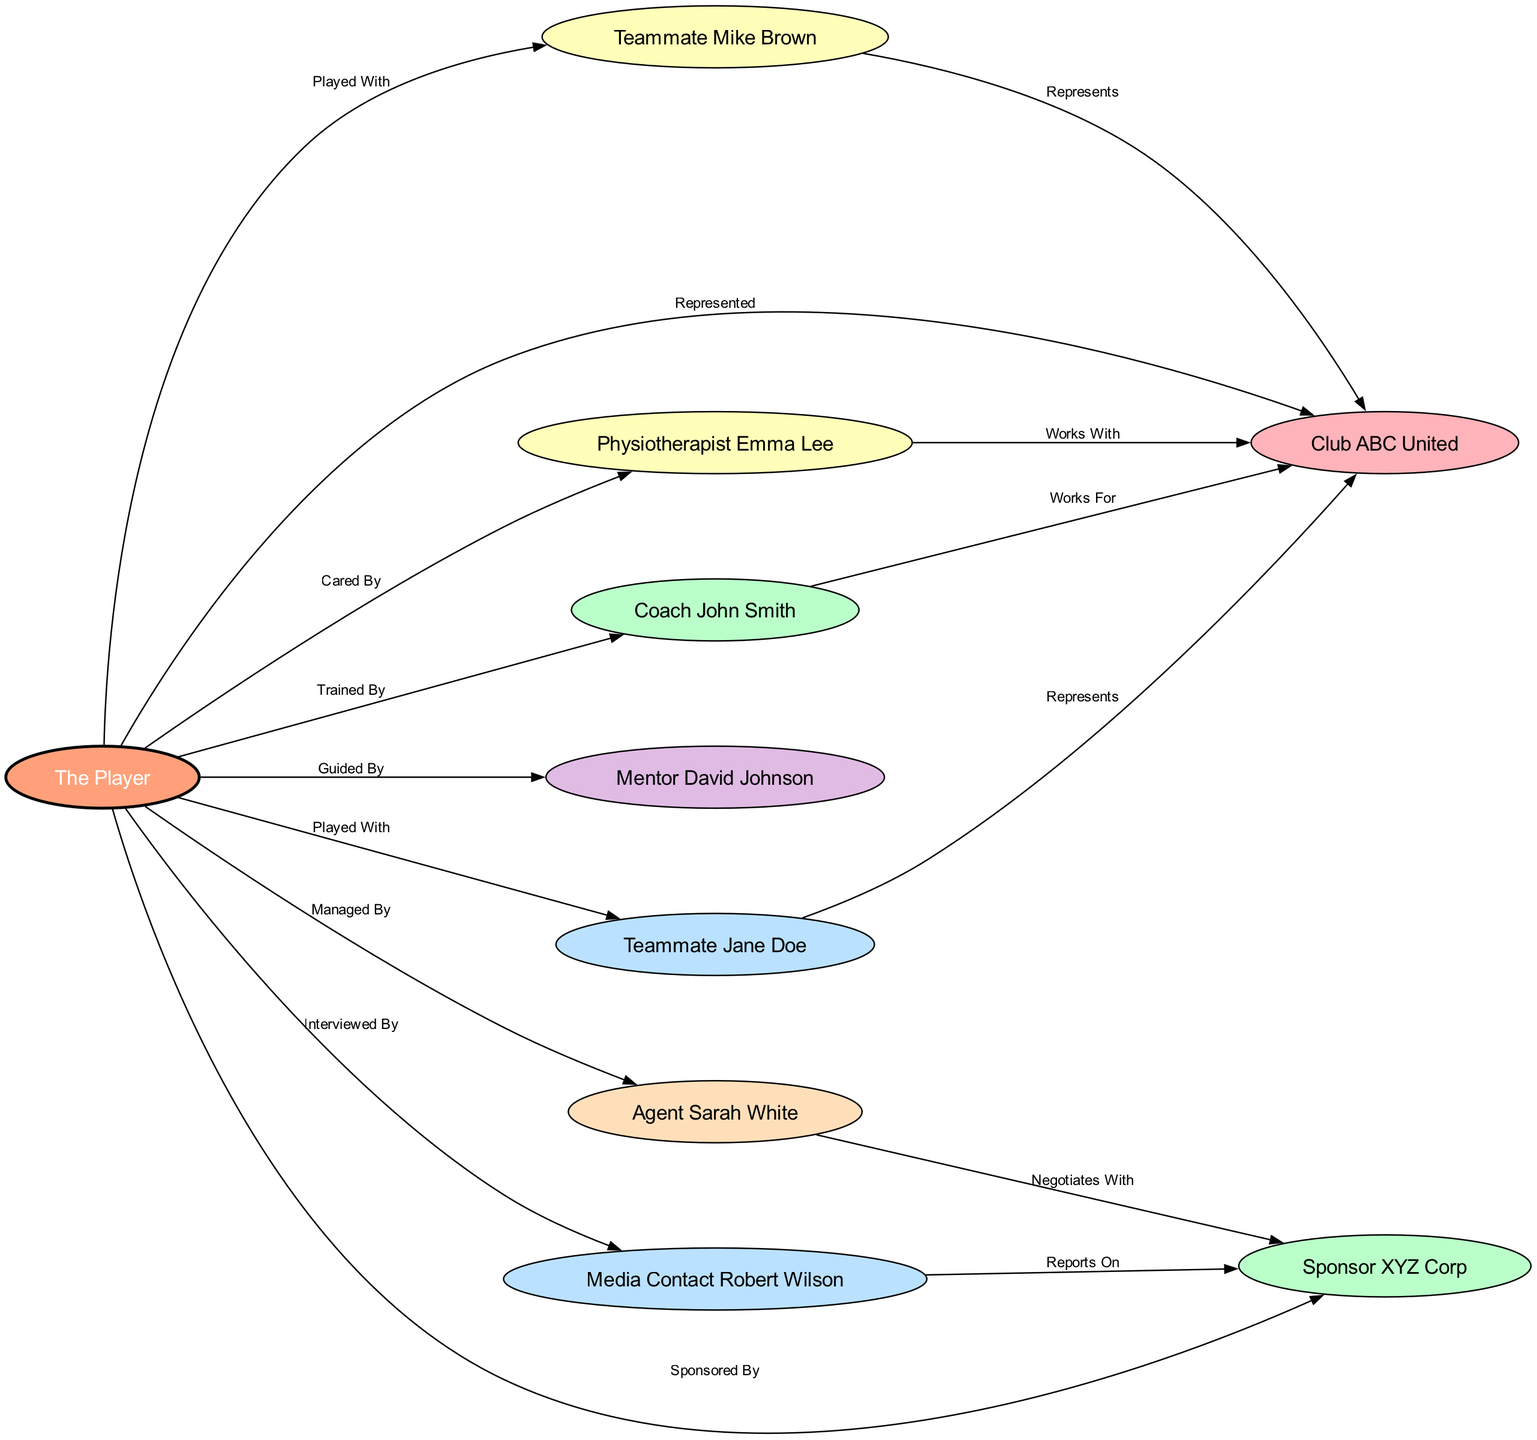What is the total number of nodes in the diagram? The diagram has nodes representing the player and key individuals. Counting the nodes in the data provided: The Player, Coach John Smith, Teammate Jane Doe, Teammate Mike Brown, Agent Sarah White, Mentor David Johnson, Club ABC United, Sponsor XYZ Corp, Media Contact Robert Wilson, and Physiotherapist Emma Lee totals 10 nodes.
Answer: 10 What relationship is indicated between the player and the coach? The edge connecting 'The Player' and 'Coach John Smith' is labeled "Trained By," indicating that the player has been trained by this coach.
Answer: Trained By Who is the agent representing the player? The player's agent is clearly labeled as "Agent Sarah White" in the nodes. This is directly listed as the edge "Managed By" leads from the player to the agent.
Answer: Agent Sarah White How many teammates are shown in the diagram? By examining the nodes, we find two teammates listed: Teammate Jane Doe and Teammate Mike Brown. This can also be confirmed by the "Played With" relationships showing connections to the player.
Answer: 2 What is the primary club represented by the player? The relationship labeled "Represented" connects the player to "Club ABC United," signifying that this is the club the player represents.
Answer: Club ABC United Which key figure negotiates with sponsors on behalf of the player? The edge labeled "Negotiates With" connects "Agent Sarah White" to "Sponsor XYZ Corp," indicating that the agent is responsible for these negotiations.
Answer: Agent Sarah White What role does Emma Lee have in relation to the player? The edge between "The Player" and "Physiotherapist Emma Lee" is labeled "Cared By," signifying Emma Lee's role in providing care to the player.
Answer: Cared By Which mentor guided the player? The diagram shows a connection from "The Player" to "Mentor David Johnson," with the edge labeled "Guided By," indicating that he provided guidance to the player.
Answer: Mentor David Johnson How many relationships involve the sponsor in the diagram? Analyzing the edges involving "Sponsor XYZ Corp," we find two relationships: one with "Agent Sarah White" (Negotiates With) and another with "Media Contact Robert Wilson" (Reports On), confirming there are two relationships.
Answer: 2 